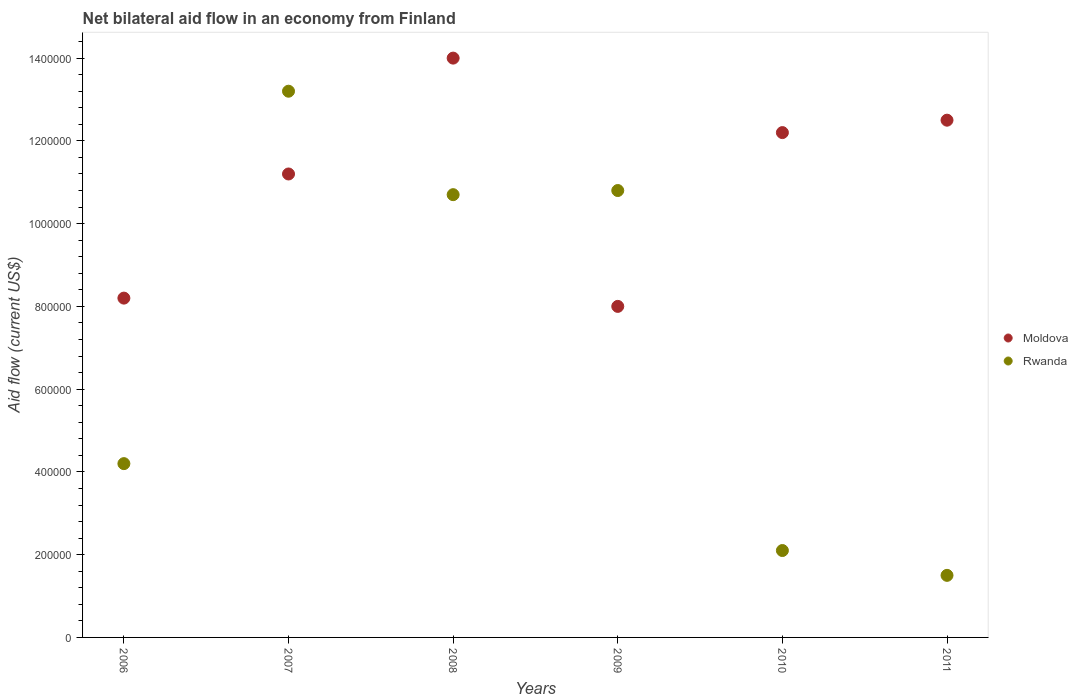What is the net bilateral aid flow in Moldova in 2006?
Provide a short and direct response. 8.20e+05. Across all years, what is the maximum net bilateral aid flow in Moldova?
Provide a succinct answer. 1.40e+06. Across all years, what is the minimum net bilateral aid flow in Rwanda?
Provide a succinct answer. 1.50e+05. In which year was the net bilateral aid flow in Moldova maximum?
Your answer should be compact. 2008. In which year was the net bilateral aid flow in Rwanda minimum?
Provide a short and direct response. 2011. What is the total net bilateral aid flow in Moldova in the graph?
Offer a very short reply. 6.61e+06. What is the difference between the net bilateral aid flow in Rwanda in 2007 and that in 2008?
Your answer should be very brief. 2.50e+05. What is the difference between the net bilateral aid flow in Moldova in 2006 and the net bilateral aid flow in Rwanda in 2009?
Offer a very short reply. -2.60e+05. What is the average net bilateral aid flow in Rwanda per year?
Your response must be concise. 7.08e+05. In the year 2010, what is the difference between the net bilateral aid flow in Rwanda and net bilateral aid flow in Moldova?
Keep it short and to the point. -1.01e+06. What is the ratio of the net bilateral aid flow in Rwanda in 2006 to that in 2008?
Give a very brief answer. 0.39. Is the net bilateral aid flow in Moldova in 2008 less than that in 2009?
Your answer should be very brief. No. Is the difference between the net bilateral aid flow in Rwanda in 2008 and 2011 greater than the difference between the net bilateral aid flow in Moldova in 2008 and 2011?
Your answer should be very brief. Yes. What is the difference between the highest and the lowest net bilateral aid flow in Rwanda?
Provide a short and direct response. 1.17e+06. Is the sum of the net bilateral aid flow in Rwanda in 2009 and 2010 greater than the maximum net bilateral aid flow in Moldova across all years?
Ensure brevity in your answer.  No. Does the net bilateral aid flow in Rwanda monotonically increase over the years?
Offer a very short reply. No. Is the net bilateral aid flow in Moldova strictly less than the net bilateral aid flow in Rwanda over the years?
Your response must be concise. No. What is the difference between two consecutive major ticks on the Y-axis?
Your answer should be very brief. 2.00e+05. Does the graph contain any zero values?
Provide a short and direct response. No. Does the graph contain grids?
Provide a short and direct response. No. How many legend labels are there?
Your answer should be very brief. 2. How are the legend labels stacked?
Your answer should be compact. Vertical. What is the title of the graph?
Ensure brevity in your answer.  Net bilateral aid flow in an economy from Finland. Does "Sweden" appear as one of the legend labels in the graph?
Your answer should be compact. No. What is the label or title of the X-axis?
Your answer should be very brief. Years. What is the label or title of the Y-axis?
Provide a short and direct response. Aid flow (current US$). What is the Aid flow (current US$) in Moldova in 2006?
Keep it short and to the point. 8.20e+05. What is the Aid flow (current US$) in Rwanda in 2006?
Provide a short and direct response. 4.20e+05. What is the Aid flow (current US$) in Moldova in 2007?
Your answer should be very brief. 1.12e+06. What is the Aid flow (current US$) of Rwanda in 2007?
Offer a very short reply. 1.32e+06. What is the Aid flow (current US$) of Moldova in 2008?
Ensure brevity in your answer.  1.40e+06. What is the Aid flow (current US$) in Rwanda in 2008?
Keep it short and to the point. 1.07e+06. What is the Aid flow (current US$) in Rwanda in 2009?
Your response must be concise. 1.08e+06. What is the Aid flow (current US$) of Moldova in 2010?
Provide a succinct answer. 1.22e+06. What is the Aid flow (current US$) in Rwanda in 2010?
Offer a very short reply. 2.10e+05. What is the Aid flow (current US$) in Moldova in 2011?
Offer a very short reply. 1.25e+06. What is the Aid flow (current US$) of Rwanda in 2011?
Give a very brief answer. 1.50e+05. Across all years, what is the maximum Aid flow (current US$) of Moldova?
Your response must be concise. 1.40e+06. Across all years, what is the maximum Aid flow (current US$) of Rwanda?
Offer a terse response. 1.32e+06. What is the total Aid flow (current US$) of Moldova in the graph?
Offer a very short reply. 6.61e+06. What is the total Aid flow (current US$) of Rwanda in the graph?
Provide a succinct answer. 4.25e+06. What is the difference between the Aid flow (current US$) of Moldova in 2006 and that in 2007?
Ensure brevity in your answer.  -3.00e+05. What is the difference between the Aid flow (current US$) in Rwanda in 2006 and that in 2007?
Ensure brevity in your answer.  -9.00e+05. What is the difference between the Aid flow (current US$) of Moldova in 2006 and that in 2008?
Provide a short and direct response. -5.80e+05. What is the difference between the Aid flow (current US$) in Rwanda in 2006 and that in 2008?
Provide a succinct answer. -6.50e+05. What is the difference between the Aid flow (current US$) of Moldova in 2006 and that in 2009?
Give a very brief answer. 2.00e+04. What is the difference between the Aid flow (current US$) of Rwanda in 2006 and that in 2009?
Provide a short and direct response. -6.60e+05. What is the difference between the Aid flow (current US$) of Moldova in 2006 and that in 2010?
Offer a terse response. -4.00e+05. What is the difference between the Aid flow (current US$) in Rwanda in 2006 and that in 2010?
Your answer should be compact. 2.10e+05. What is the difference between the Aid flow (current US$) in Moldova in 2006 and that in 2011?
Your response must be concise. -4.30e+05. What is the difference between the Aid flow (current US$) in Rwanda in 2006 and that in 2011?
Offer a terse response. 2.70e+05. What is the difference between the Aid flow (current US$) of Moldova in 2007 and that in 2008?
Offer a terse response. -2.80e+05. What is the difference between the Aid flow (current US$) of Rwanda in 2007 and that in 2008?
Your response must be concise. 2.50e+05. What is the difference between the Aid flow (current US$) in Rwanda in 2007 and that in 2010?
Offer a very short reply. 1.11e+06. What is the difference between the Aid flow (current US$) of Rwanda in 2007 and that in 2011?
Offer a terse response. 1.17e+06. What is the difference between the Aid flow (current US$) in Moldova in 2008 and that in 2010?
Ensure brevity in your answer.  1.80e+05. What is the difference between the Aid flow (current US$) in Rwanda in 2008 and that in 2010?
Offer a very short reply. 8.60e+05. What is the difference between the Aid flow (current US$) in Rwanda in 2008 and that in 2011?
Your answer should be very brief. 9.20e+05. What is the difference between the Aid flow (current US$) in Moldova in 2009 and that in 2010?
Offer a terse response. -4.20e+05. What is the difference between the Aid flow (current US$) in Rwanda in 2009 and that in 2010?
Your answer should be very brief. 8.70e+05. What is the difference between the Aid flow (current US$) in Moldova in 2009 and that in 2011?
Give a very brief answer. -4.50e+05. What is the difference between the Aid flow (current US$) of Rwanda in 2009 and that in 2011?
Your answer should be compact. 9.30e+05. What is the difference between the Aid flow (current US$) in Rwanda in 2010 and that in 2011?
Provide a succinct answer. 6.00e+04. What is the difference between the Aid flow (current US$) of Moldova in 2006 and the Aid flow (current US$) of Rwanda in 2007?
Your answer should be compact. -5.00e+05. What is the difference between the Aid flow (current US$) of Moldova in 2006 and the Aid flow (current US$) of Rwanda in 2008?
Your answer should be compact. -2.50e+05. What is the difference between the Aid flow (current US$) of Moldova in 2006 and the Aid flow (current US$) of Rwanda in 2009?
Provide a short and direct response. -2.60e+05. What is the difference between the Aid flow (current US$) of Moldova in 2006 and the Aid flow (current US$) of Rwanda in 2010?
Give a very brief answer. 6.10e+05. What is the difference between the Aid flow (current US$) in Moldova in 2006 and the Aid flow (current US$) in Rwanda in 2011?
Your answer should be very brief. 6.70e+05. What is the difference between the Aid flow (current US$) in Moldova in 2007 and the Aid flow (current US$) in Rwanda in 2008?
Provide a short and direct response. 5.00e+04. What is the difference between the Aid flow (current US$) of Moldova in 2007 and the Aid flow (current US$) of Rwanda in 2009?
Give a very brief answer. 4.00e+04. What is the difference between the Aid flow (current US$) of Moldova in 2007 and the Aid flow (current US$) of Rwanda in 2010?
Make the answer very short. 9.10e+05. What is the difference between the Aid flow (current US$) of Moldova in 2007 and the Aid flow (current US$) of Rwanda in 2011?
Offer a very short reply. 9.70e+05. What is the difference between the Aid flow (current US$) in Moldova in 2008 and the Aid flow (current US$) in Rwanda in 2009?
Provide a succinct answer. 3.20e+05. What is the difference between the Aid flow (current US$) of Moldova in 2008 and the Aid flow (current US$) of Rwanda in 2010?
Provide a succinct answer. 1.19e+06. What is the difference between the Aid flow (current US$) in Moldova in 2008 and the Aid flow (current US$) in Rwanda in 2011?
Your answer should be very brief. 1.25e+06. What is the difference between the Aid flow (current US$) of Moldova in 2009 and the Aid flow (current US$) of Rwanda in 2010?
Give a very brief answer. 5.90e+05. What is the difference between the Aid flow (current US$) in Moldova in 2009 and the Aid flow (current US$) in Rwanda in 2011?
Keep it short and to the point. 6.50e+05. What is the difference between the Aid flow (current US$) in Moldova in 2010 and the Aid flow (current US$) in Rwanda in 2011?
Offer a terse response. 1.07e+06. What is the average Aid flow (current US$) of Moldova per year?
Keep it short and to the point. 1.10e+06. What is the average Aid flow (current US$) in Rwanda per year?
Provide a short and direct response. 7.08e+05. In the year 2006, what is the difference between the Aid flow (current US$) of Moldova and Aid flow (current US$) of Rwanda?
Give a very brief answer. 4.00e+05. In the year 2007, what is the difference between the Aid flow (current US$) of Moldova and Aid flow (current US$) of Rwanda?
Your answer should be very brief. -2.00e+05. In the year 2008, what is the difference between the Aid flow (current US$) of Moldova and Aid flow (current US$) of Rwanda?
Your response must be concise. 3.30e+05. In the year 2009, what is the difference between the Aid flow (current US$) in Moldova and Aid flow (current US$) in Rwanda?
Offer a terse response. -2.80e+05. In the year 2010, what is the difference between the Aid flow (current US$) in Moldova and Aid flow (current US$) in Rwanda?
Your answer should be compact. 1.01e+06. In the year 2011, what is the difference between the Aid flow (current US$) in Moldova and Aid flow (current US$) in Rwanda?
Offer a very short reply. 1.10e+06. What is the ratio of the Aid flow (current US$) of Moldova in 2006 to that in 2007?
Your answer should be very brief. 0.73. What is the ratio of the Aid flow (current US$) of Rwanda in 2006 to that in 2007?
Give a very brief answer. 0.32. What is the ratio of the Aid flow (current US$) of Moldova in 2006 to that in 2008?
Ensure brevity in your answer.  0.59. What is the ratio of the Aid flow (current US$) in Rwanda in 2006 to that in 2008?
Give a very brief answer. 0.39. What is the ratio of the Aid flow (current US$) in Rwanda in 2006 to that in 2009?
Provide a succinct answer. 0.39. What is the ratio of the Aid flow (current US$) in Moldova in 2006 to that in 2010?
Offer a terse response. 0.67. What is the ratio of the Aid flow (current US$) in Rwanda in 2006 to that in 2010?
Give a very brief answer. 2. What is the ratio of the Aid flow (current US$) of Moldova in 2006 to that in 2011?
Provide a succinct answer. 0.66. What is the ratio of the Aid flow (current US$) in Rwanda in 2006 to that in 2011?
Make the answer very short. 2.8. What is the ratio of the Aid flow (current US$) in Moldova in 2007 to that in 2008?
Ensure brevity in your answer.  0.8. What is the ratio of the Aid flow (current US$) in Rwanda in 2007 to that in 2008?
Make the answer very short. 1.23. What is the ratio of the Aid flow (current US$) in Moldova in 2007 to that in 2009?
Your answer should be very brief. 1.4. What is the ratio of the Aid flow (current US$) of Rwanda in 2007 to that in 2009?
Give a very brief answer. 1.22. What is the ratio of the Aid flow (current US$) in Moldova in 2007 to that in 2010?
Give a very brief answer. 0.92. What is the ratio of the Aid flow (current US$) of Rwanda in 2007 to that in 2010?
Your answer should be very brief. 6.29. What is the ratio of the Aid flow (current US$) in Moldova in 2007 to that in 2011?
Offer a very short reply. 0.9. What is the ratio of the Aid flow (current US$) in Rwanda in 2007 to that in 2011?
Your answer should be compact. 8.8. What is the ratio of the Aid flow (current US$) in Moldova in 2008 to that in 2009?
Offer a terse response. 1.75. What is the ratio of the Aid flow (current US$) of Rwanda in 2008 to that in 2009?
Keep it short and to the point. 0.99. What is the ratio of the Aid flow (current US$) of Moldova in 2008 to that in 2010?
Provide a short and direct response. 1.15. What is the ratio of the Aid flow (current US$) in Rwanda in 2008 to that in 2010?
Your answer should be very brief. 5.1. What is the ratio of the Aid flow (current US$) of Moldova in 2008 to that in 2011?
Make the answer very short. 1.12. What is the ratio of the Aid flow (current US$) in Rwanda in 2008 to that in 2011?
Offer a very short reply. 7.13. What is the ratio of the Aid flow (current US$) of Moldova in 2009 to that in 2010?
Offer a very short reply. 0.66. What is the ratio of the Aid flow (current US$) in Rwanda in 2009 to that in 2010?
Ensure brevity in your answer.  5.14. What is the ratio of the Aid flow (current US$) of Moldova in 2009 to that in 2011?
Your response must be concise. 0.64. What is the ratio of the Aid flow (current US$) in Rwanda in 2009 to that in 2011?
Keep it short and to the point. 7.2. What is the difference between the highest and the lowest Aid flow (current US$) in Moldova?
Provide a short and direct response. 6.00e+05. What is the difference between the highest and the lowest Aid flow (current US$) in Rwanda?
Offer a very short reply. 1.17e+06. 